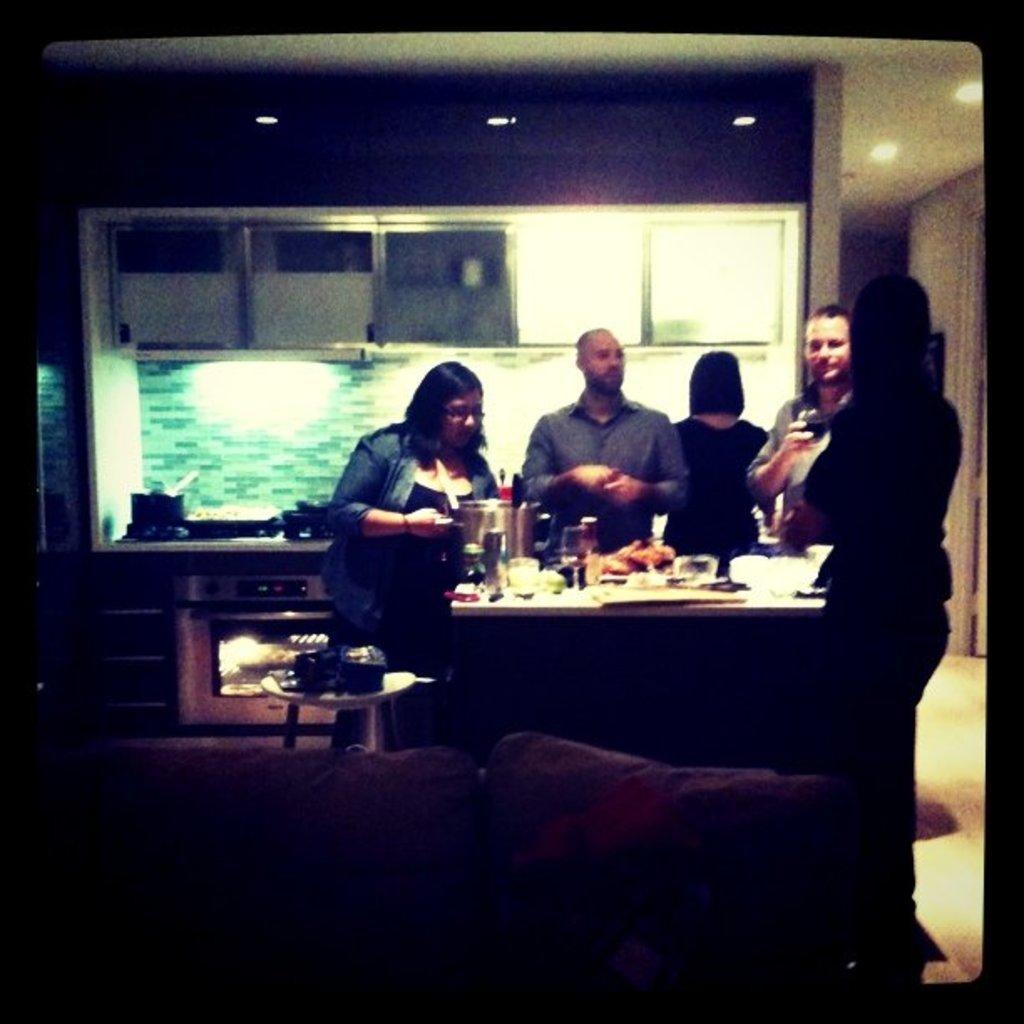In one or two sentences, can you explain what this image depicts? This picture is clicked inside a room. In the center of the image there is a table and there are people around it. On the table there are glasses, food and jar. To the below of the image there is a couch and behind it there is a stool. In the background there is wall, cupboards, micro-oven. There are lights to the ceiling. 